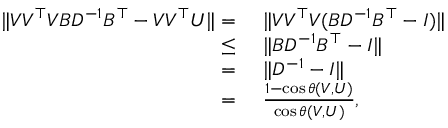<formula> <loc_0><loc_0><loc_500><loc_500>\begin{array} { r l } { \| V V ^ { \top } V B D ^ { - 1 } B ^ { \top } - V V ^ { \top } U \| = } & { \| V V ^ { \top } V ( B D ^ { - 1 } B ^ { \top } - I ) \| } \\ { \leq } & { \| B D ^ { - 1 } B ^ { \top } - I \| } \\ { = } & { \| D ^ { - 1 } - I \| } \\ { = } & { \frac { 1 - \cos \theta ( V , U ) } { \cos \theta ( V , U ) } , } \end{array}</formula> 